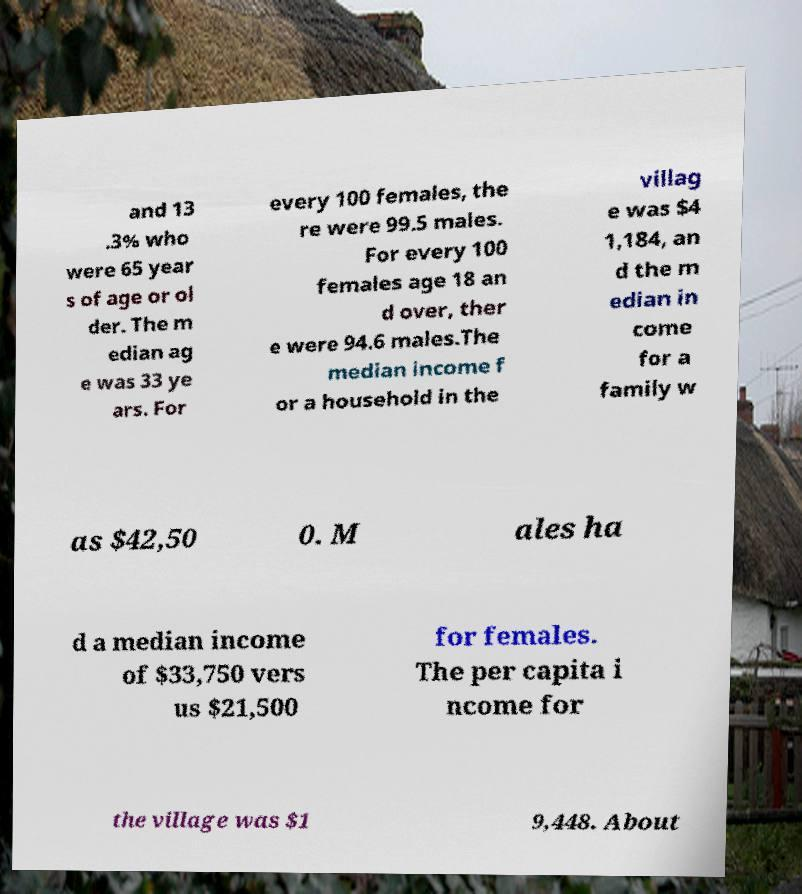For documentation purposes, I need the text within this image transcribed. Could you provide that? and 13 .3% who were 65 year s of age or ol der. The m edian ag e was 33 ye ars. For every 100 females, the re were 99.5 males. For every 100 females age 18 an d over, ther e were 94.6 males.The median income f or a household in the villag e was $4 1,184, an d the m edian in come for a family w as $42,50 0. M ales ha d a median income of $33,750 vers us $21,500 for females. The per capita i ncome for the village was $1 9,448. About 